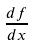<formula> <loc_0><loc_0><loc_500><loc_500>\frac { d f } { d x }</formula> 